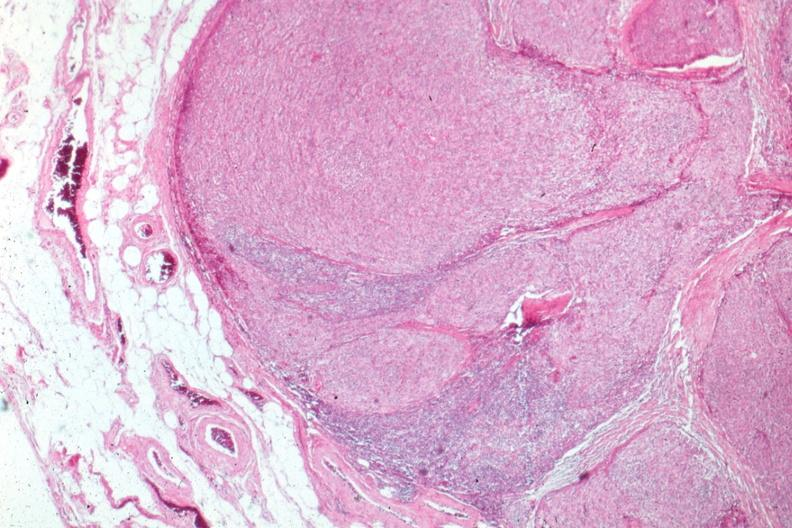what is present?
Answer the question using a single word or phrase. Thymus 